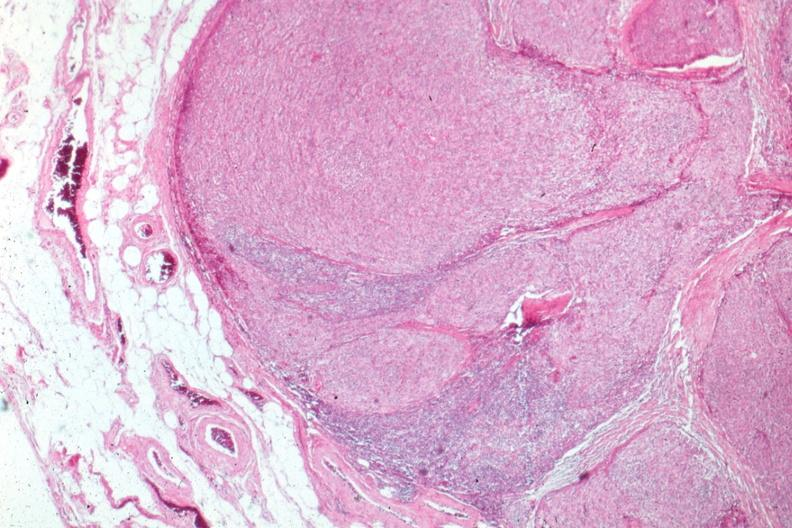what is present?
Answer the question using a single word or phrase. Thymus 